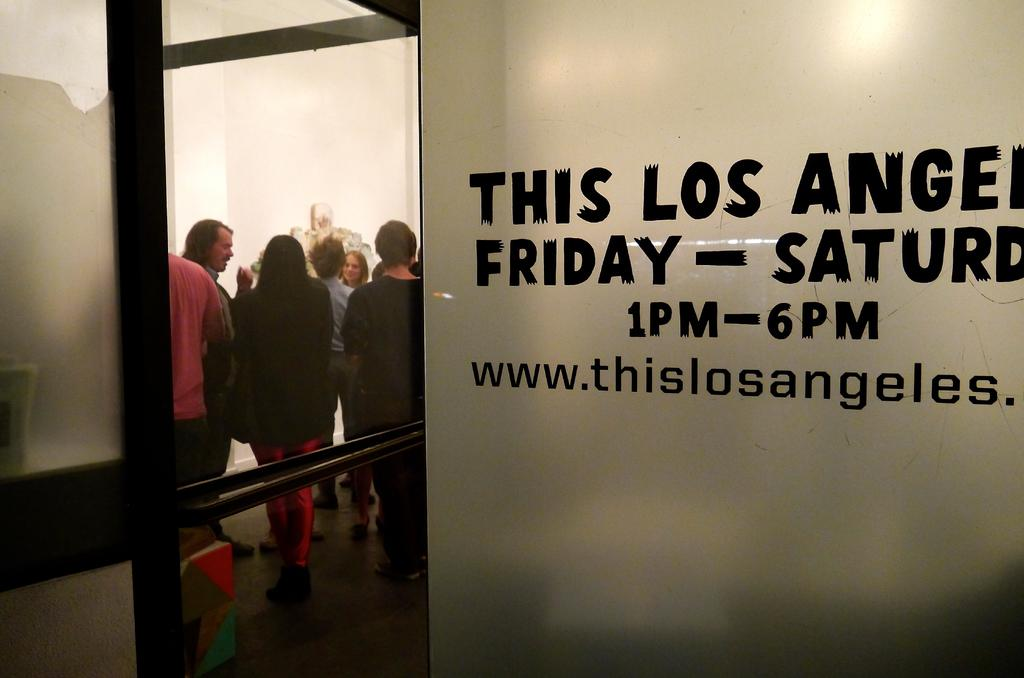<image>
Render a clear and concise summary of the photo. A line of people going inside to listen to This Los Angeles from 1 pm till 6 pm. 